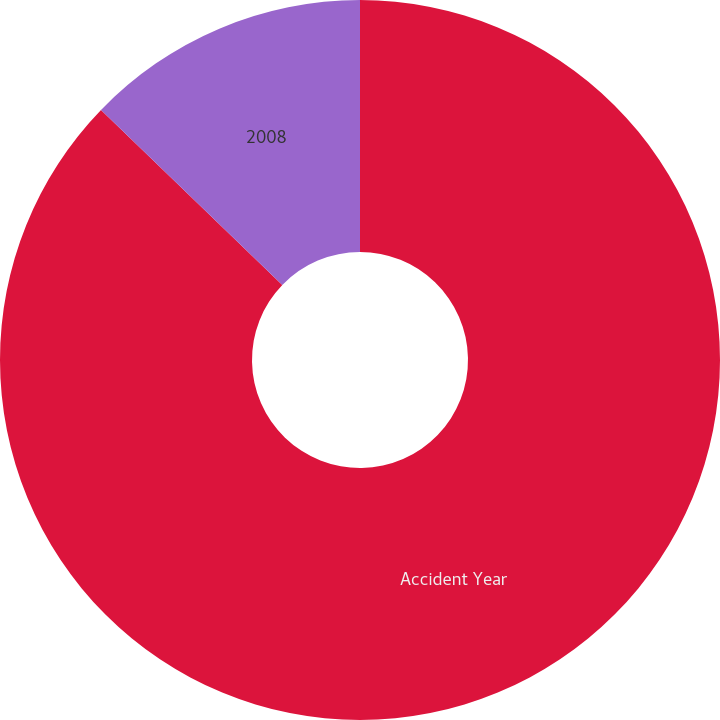<chart> <loc_0><loc_0><loc_500><loc_500><pie_chart><fcel>Accident Year<fcel>2008<nl><fcel>87.22%<fcel>12.78%<nl></chart> 